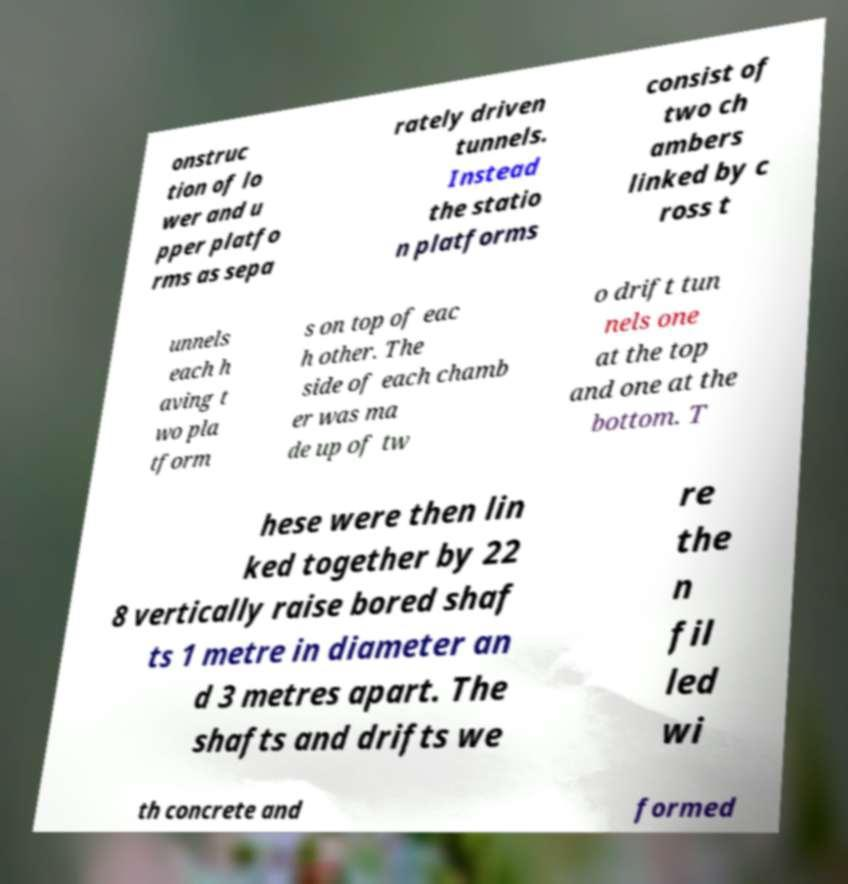There's text embedded in this image that I need extracted. Can you transcribe it verbatim? onstruc tion of lo wer and u pper platfo rms as sepa rately driven tunnels. Instead the statio n platforms consist of two ch ambers linked by c ross t unnels each h aving t wo pla tform s on top of eac h other. The side of each chamb er was ma de up of tw o drift tun nels one at the top and one at the bottom. T hese were then lin ked together by 22 8 vertically raise bored shaf ts 1 metre in diameter an d 3 metres apart. The shafts and drifts we re the n fil led wi th concrete and formed 